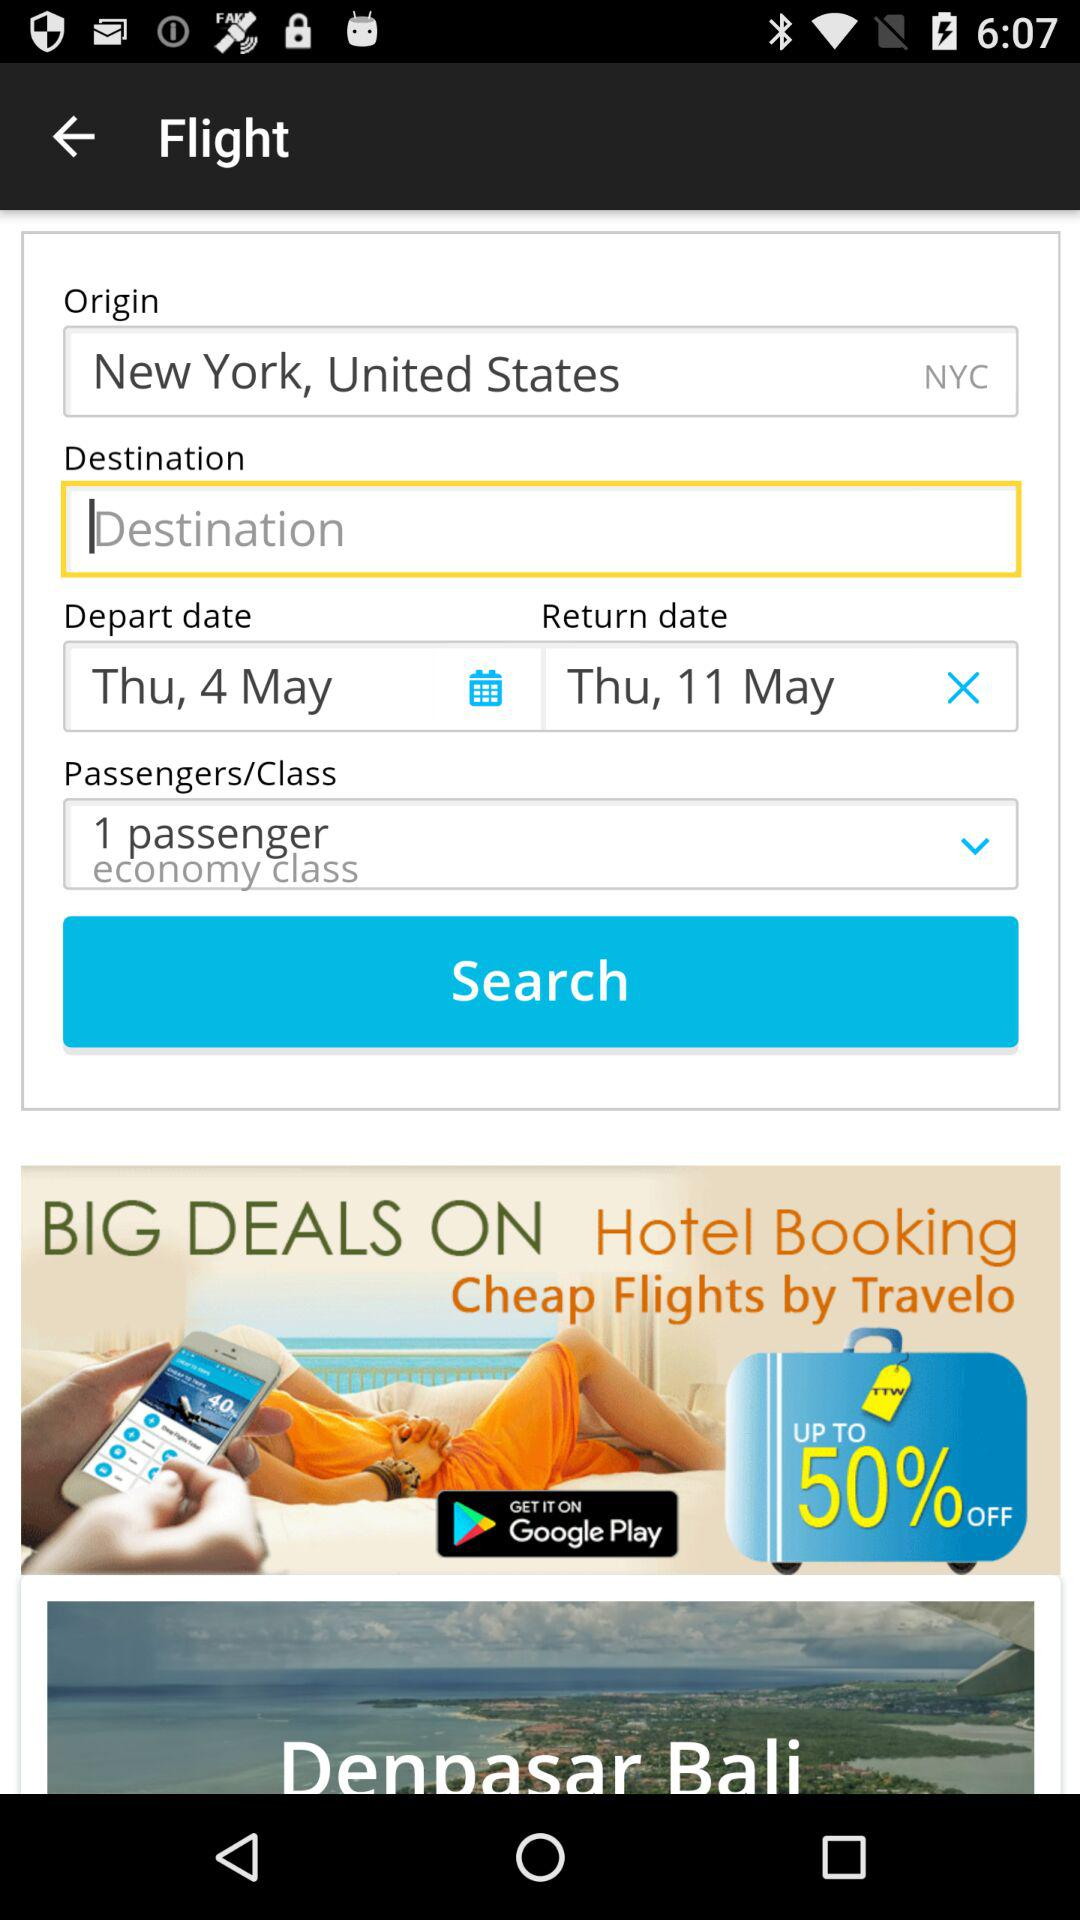How many passengers are there? There is 1 passenger. 